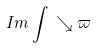<formula> <loc_0><loc_0><loc_500><loc_500>I m \int \, \searrow \varpi</formula> 